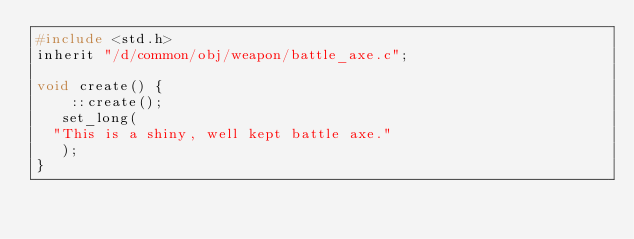<code> <loc_0><loc_0><loc_500><loc_500><_C_>#include <std.h>
inherit "/d/common/obj/weapon/battle_axe.c";

void create() {
    ::create();
   set_long(
	"This is a shiny, well kept battle axe."
   );
}
</code> 